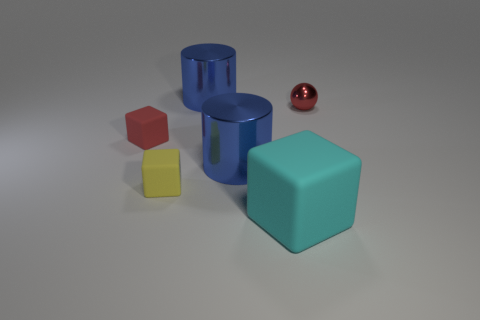Add 2 small red balls. How many objects exist? 8 Subtract all spheres. How many objects are left? 5 Add 1 big blue cylinders. How many big blue cylinders exist? 3 Subtract 0 green balls. How many objects are left? 6 Subtract all big matte things. Subtract all small cyan matte blocks. How many objects are left? 5 Add 3 red spheres. How many red spheres are left? 4 